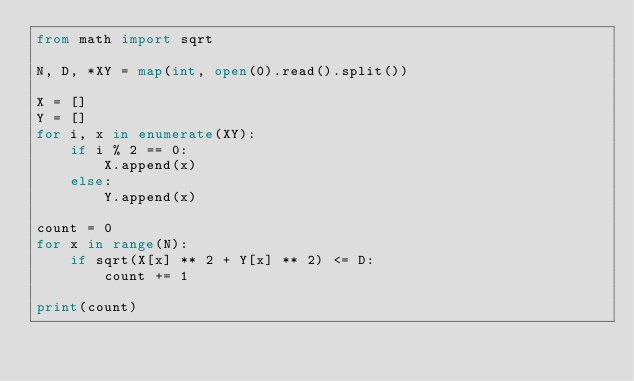<code> <loc_0><loc_0><loc_500><loc_500><_Python_>from math import sqrt

N, D, *XY = map(int, open(0).read().split())

X = []
Y = []
for i, x in enumerate(XY):
    if i % 2 == 0:
        X.append(x)
    else:
        Y.append(x)

count = 0
for x in range(N):
    if sqrt(X[x] ** 2 + Y[x] ** 2) <= D:
        count += 1

print(count)</code> 